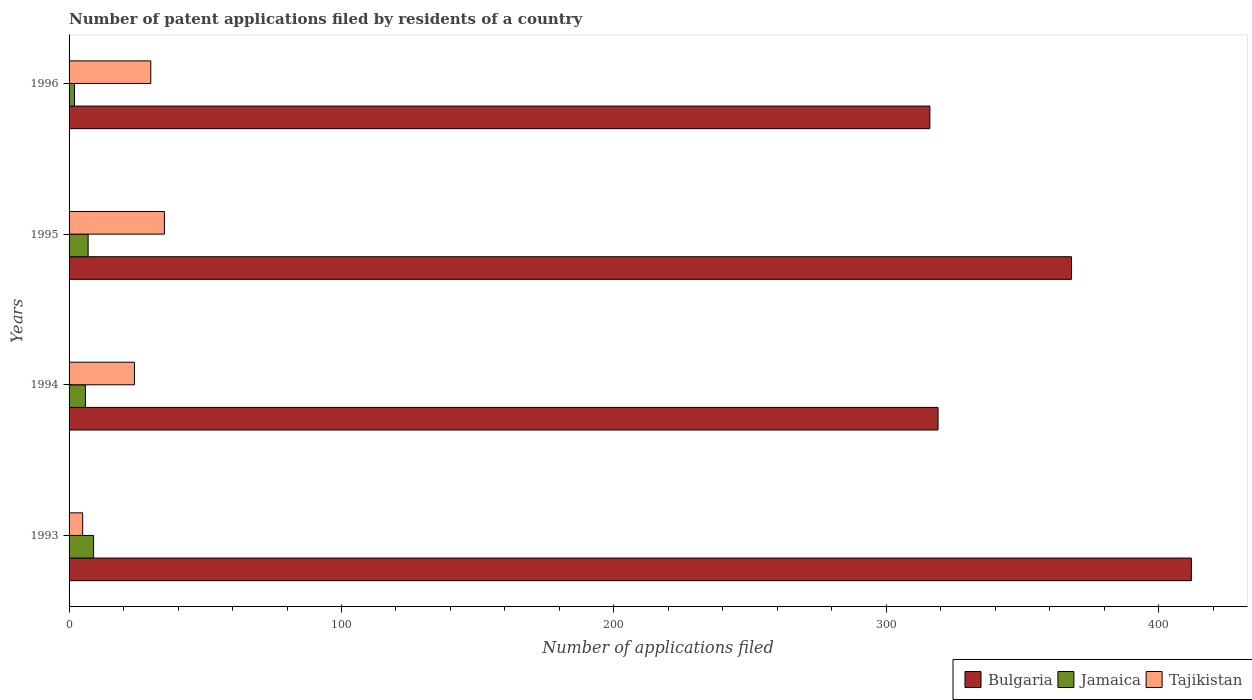Are the number of bars on each tick of the Y-axis equal?
Your answer should be very brief. Yes. What is the label of the 1st group of bars from the top?
Offer a terse response. 1996. In how many cases, is the number of bars for a given year not equal to the number of legend labels?
Your response must be concise. 0. Across all years, what is the minimum number of applications filed in Bulgaria?
Your answer should be compact. 316. In which year was the number of applications filed in Tajikistan maximum?
Offer a terse response. 1995. What is the total number of applications filed in Tajikistan in the graph?
Ensure brevity in your answer.  94. What is the difference between the number of applications filed in Bulgaria in 1994 and that in 1995?
Ensure brevity in your answer.  -49. What is the difference between the number of applications filed in Jamaica in 1994 and the number of applications filed in Bulgaria in 1995?
Keep it short and to the point. -362. What is the average number of applications filed in Jamaica per year?
Your answer should be compact. 6. In the year 1994, what is the difference between the number of applications filed in Bulgaria and number of applications filed in Jamaica?
Make the answer very short. 313. In how many years, is the number of applications filed in Bulgaria greater than 220 ?
Provide a succinct answer. 4. What is the ratio of the number of applications filed in Bulgaria in 1995 to that in 1996?
Make the answer very short. 1.16. Is the number of applications filed in Tajikistan in 1995 less than that in 1996?
Your answer should be compact. No. What is the difference between the highest and the lowest number of applications filed in Bulgaria?
Your response must be concise. 96. What does the 1st bar from the top in 1996 represents?
Make the answer very short. Tajikistan. What does the 3rd bar from the bottom in 1994 represents?
Offer a very short reply. Tajikistan. Is it the case that in every year, the sum of the number of applications filed in Bulgaria and number of applications filed in Jamaica is greater than the number of applications filed in Tajikistan?
Give a very brief answer. Yes. How many bars are there?
Keep it short and to the point. 12. Are all the bars in the graph horizontal?
Keep it short and to the point. Yes. What is the difference between two consecutive major ticks on the X-axis?
Make the answer very short. 100. Does the graph contain grids?
Offer a terse response. No. How are the legend labels stacked?
Provide a succinct answer. Horizontal. What is the title of the graph?
Ensure brevity in your answer.  Number of patent applications filed by residents of a country. Does "El Salvador" appear as one of the legend labels in the graph?
Ensure brevity in your answer.  No. What is the label or title of the X-axis?
Make the answer very short. Number of applications filed. What is the label or title of the Y-axis?
Your answer should be very brief. Years. What is the Number of applications filed of Bulgaria in 1993?
Your answer should be very brief. 412. What is the Number of applications filed of Bulgaria in 1994?
Provide a succinct answer. 319. What is the Number of applications filed in Tajikistan in 1994?
Your answer should be compact. 24. What is the Number of applications filed of Bulgaria in 1995?
Offer a very short reply. 368. What is the Number of applications filed in Tajikistan in 1995?
Your response must be concise. 35. What is the Number of applications filed in Bulgaria in 1996?
Provide a short and direct response. 316. What is the Number of applications filed of Jamaica in 1996?
Provide a short and direct response. 2. Across all years, what is the maximum Number of applications filed of Bulgaria?
Give a very brief answer. 412. Across all years, what is the maximum Number of applications filed of Tajikistan?
Provide a succinct answer. 35. Across all years, what is the minimum Number of applications filed of Bulgaria?
Provide a short and direct response. 316. Across all years, what is the minimum Number of applications filed in Tajikistan?
Provide a succinct answer. 5. What is the total Number of applications filed of Bulgaria in the graph?
Ensure brevity in your answer.  1415. What is the total Number of applications filed of Tajikistan in the graph?
Offer a terse response. 94. What is the difference between the Number of applications filed in Bulgaria in 1993 and that in 1994?
Give a very brief answer. 93. What is the difference between the Number of applications filed in Bulgaria in 1993 and that in 1995?
Offer a terse response. 44. What is the difference between the Number of applications filed in Tajikistan in 1993 and that in 1995?
Give a very brief answer. -30. What is the difference between the Number of applications filed of Bulgaria in 1993 and that in 1996?
Your answer should be very brief. 96. What is the difference between the Number of applications filed of Jamaica in 1993 and that in 1996?
Provide a succinct answer. 7. What is the difference between the Number of applications filed in Tajikistan in 1993 and that in 1996?
Your answer should be compact. -25. What is the difference between the Number of applications filed of Bulgaria in 1994 and that in 1995?
Your answer should be very brief. -49. What is the difference between the Number of applications filed of Bulgaria in 1995 and that in 1996?
Your answer should be compact. 52. What is the difference between the Number of applications filed in Jamaica in 1995 and that in 1996?
Give a very brief answer. 5. What is the difference between the Number of applications filed in Bulgaria in 1993 and the Number of applications filed in Jamaica in 1994?
Ensure brevity in your answer.  406. What is the difference between the Number of applications filed of Bulgaria in 1993 and the Number of applications filed of Tajikistan in 1994?
Your response must be concise. 388. What is the difference between the Number of applications filed of Jamaica in 1993 and the Number of applications filed of Tajikistan in 1994?
Ensure brevity in your answer.  -15. What is the difference between the Number of applications filed of Bulgaria in 1993 and the Number of applications filed of Jamaica in 1995?
Offer a very short reply. 405. What is the difference between the Number of applications filed of Bulgaria in 1993 and the Number of applications filed of Tajikistan in 1995?
Your answer should be compact. 377. What is the difference between the Number of applications filed in Bulgaria in 1993 and the Number of applications filed in Jamaica in 1996?
Your answer should be very brief. 410. What is the difference between the Number of applications filed in Bulgaria in 1993 and the Number of applications filed in Tajikistan in 1996?
Make the answer very short. 382. What is the difference between the Number of applications filed in Bulgaria in 1994 and the Number of applications filed in Jamaica in 1995?
Provide a short and direct response. 312. What is the difference between the Number of applications filed of Bulgaria in 1994 and the Number of applications filed of Tajikistan in 1995?
Provide a short and direct response. 284. What is the difference between the Number of applications filed in Bulgaria in 1994 and the Number of applications filed in Jamaica in 1996?
Your answer should be compact. 317. What is the difference between the Number of applications filed in Bulgaria in 1994 and the Number of applications filed in Tajikistan in 1996?
Offer a terse response. 289. What is the difference between the Number of applications filed in Bulgaria in 1995 and the Number of applications filed in Jamaica in 1996?
Provide a short and direct response. 366. What is the difference between the Number of applications filed in Bulgaria in 1995 and the Number of applications filed in Tajikistan in 1996?
Your answer should be very brief. 338. What is the average Number of applications filed in Bulgaria per year?
Make the answer very short. 353.75. What is the average Number of applications filed in Jamaica per year?
Offer a very short reply. 6. In the year 1993, what is the difference between the Number of applications filed in Bulgaria and Number of applications filed in Jamaica?
Your answer should be very brief. 403. In the year 1993, what is the difference between the Number of applications filed in Bulgaria and Number of applications filed in Tajikistan?
Your response must be concise. 407. In the year 1994, what is the difference between the Number of applications filed in Bulgaria and Number of applications filed in Jamaica?
Provide a short and direct response. 313. In the year 1994, what is the difference between the Number of applications filed in Bulgaria and Number of applications filed in Tajikistan?
Make the answer very short. 295. In the year 1995, what is the difference between the Number of applications filed in Bulgaria and Number of applications filed in Jamaica?
Give a very brief answer. 361. In the year 1995, what is the difference between the Number of applications filed in Bulgaria and Number of applications filed in Tajikistan?
Provide a short and direct response. 333. In the year 1996, what is the difference between the Number of applications filed in Bulgaria and Number of applications filed in Jamaica?
Your response must be concise. 314. In the year 1996, what is the difference between the Number of applications filed of Bulgaria and Number of applications filed of Tajikistan?
Give a very brief answer. 286. In the year 1996, what is the difference between the Number of applications filed in Jamaica and Number of applications filed in Tajikistan?
Provide a succinct answer. -28. What is the ratio of the Number of applications filed in Bulgaria in 1993 to that in 1994?
Your answer should be compact. 1.29. What is the ratio of the Number of applications filed of Tajikistan in 1993 to that in 1994?
Provide a succinct answer. 0.21. What is the ratio of the Number of applications filed of Bulgaria in 1993 to that in 1995?
Offer a very short reply. 1.12. What is the ratio of the Number of applications filed of Tajikistan in 1993 to that in 1995?
Your answer should be compact. 0.14. What is the ratio of the Number of applications filed of Bulgaria in 1993 to that in 1996?
Make the answer very short. 1.3. What is the ratio of the Number of applications filed of Jamaica in 1993 to that in 1996?
Provide a succinct answer. 4.5. What is the ratio of the Number of applications filed in Tajikistan in 1993 to that in 1996?
Offer a very short reply. 0.17. What is the ratio of the Number of applications filed of Bulgaria in 1994 to that in 1995?
Provide a succinct answer. 0.87. What is the ratio of the Number of applications filed of Jamaica in 1994 to that in 1995?
Your response must be concise. 0.86. What is the ratio of the Number of applications filed of Tajikistan in 1994 to that in 1995?
Your answer should be compact. 0.69. What is the ratio of the Number of applications filed in Bulgaria in 1994 to that in 1996?
Provide a succinct answer. 1.01. What is the ratio of the Number of applications filed in Jamaica in 1994 to that in 1996?
Ensure brevity in your answer.  3. What is the ratio of the Number of applications filed in Bulgaria in 1995 to that in 1996?
Provide a short and direct response. 1.16. What is the difference between the highest and the second highest Number of applications filed in Bulgaria?
Give a very brief answer. 44. What is the difference between the highest and the second highest Number of applications filed of Tajikistan?
Offer a very short reply. 5. What is the difference between the highest and the lowest Number of applications filed in Bulgaria?
Your response must be concise. 96. What is the difference between the highest and the lowest Number of applications filed in Jamaica?
Make the answer very short. 7. 